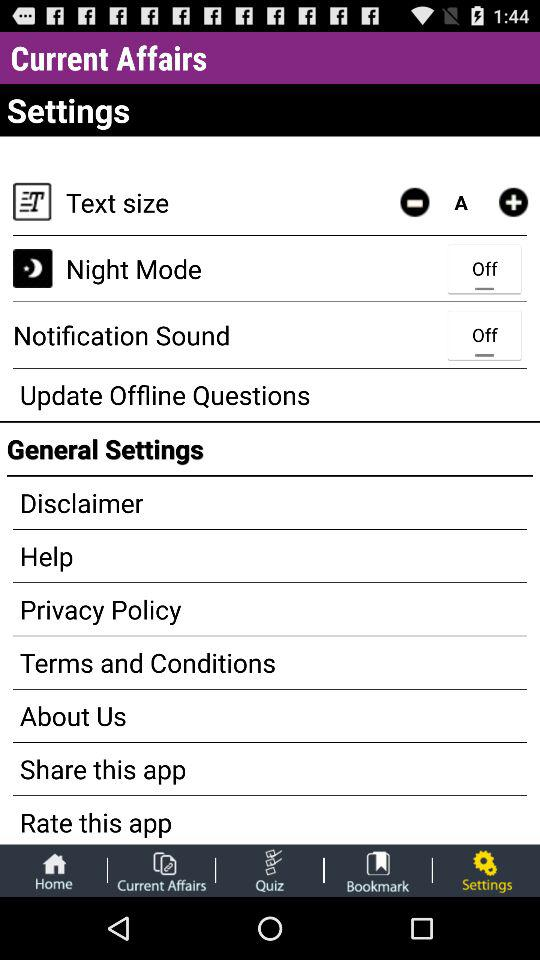What is the application name? The application name is "Current Affairs". 